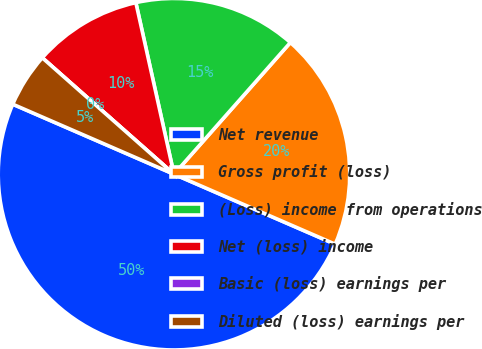Convert chart. <chart><loc_0><loc_0><loc_500><loc_500><pie_chart><fcel>Net revenue<fcel>Gross profit (loss)<fcel>(Loss) income from operations<fcel>Net (loss) income<fcel>Basic (loss) earnings per<fcel>Diluted (loss) earnings per<nl><fcel>50.0%<fcel>20.0%<fcel>15.0%<fcel>10.0%<fcel>0.0%<fcel>5.0%<nl></chart> 